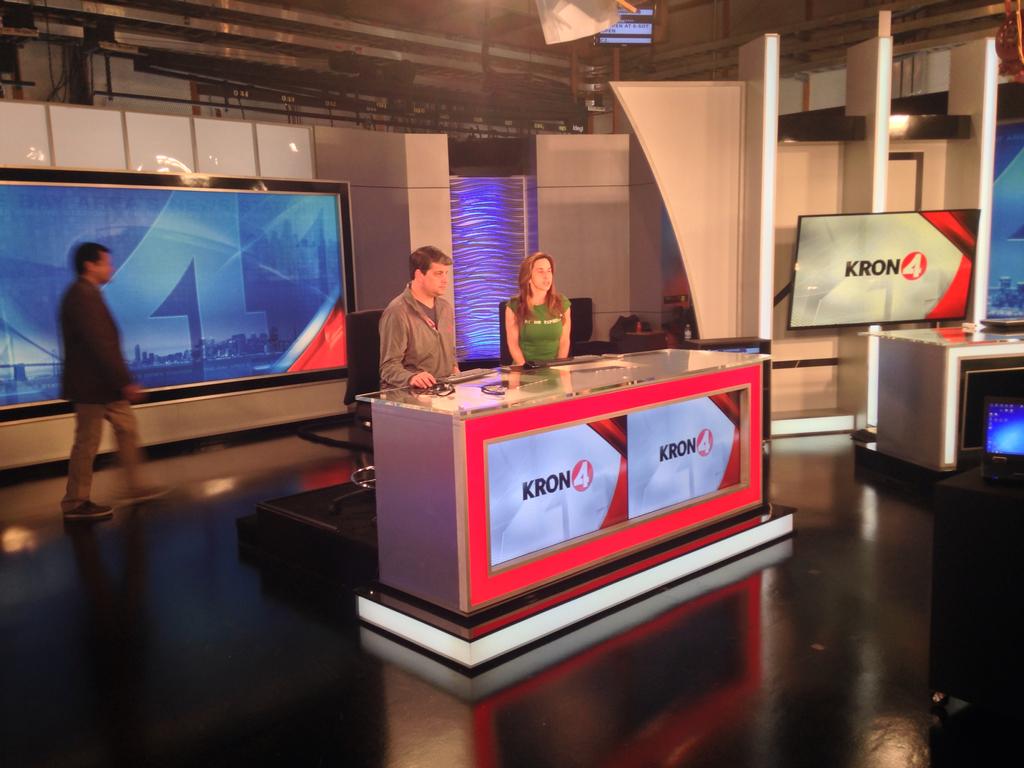What news station is this?
Your answer should be very brief. Kron4. 